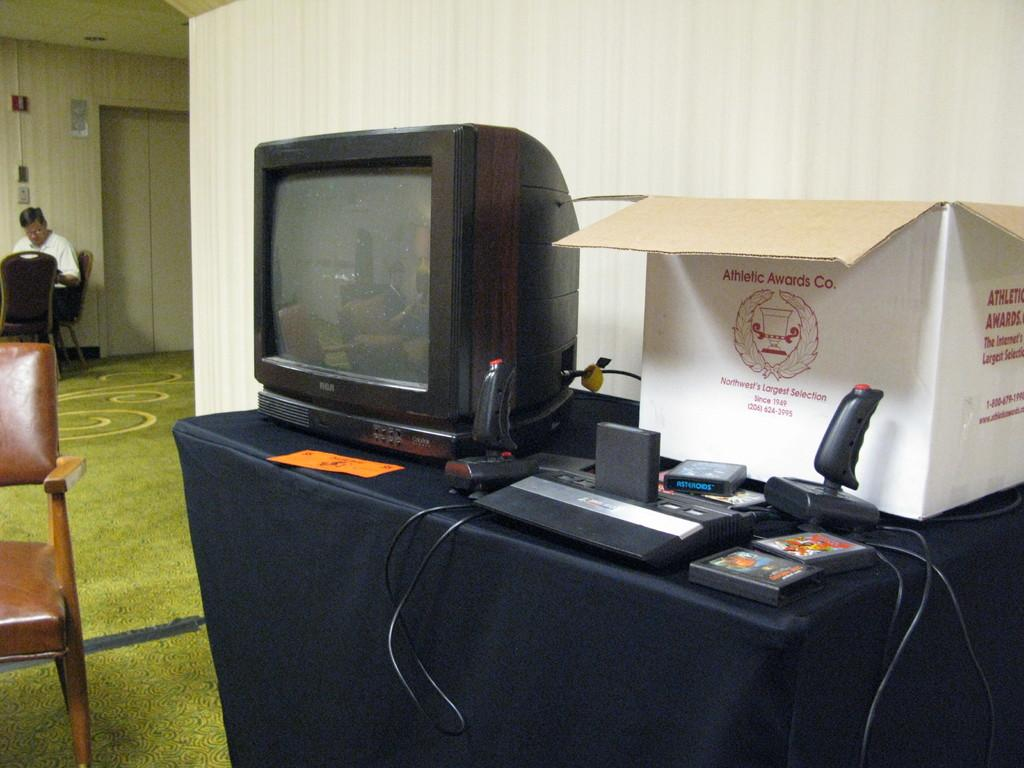Provide a one-sentence caption for the provided image. An old TV is on a table next to a box that says Athletic Awards Co. 